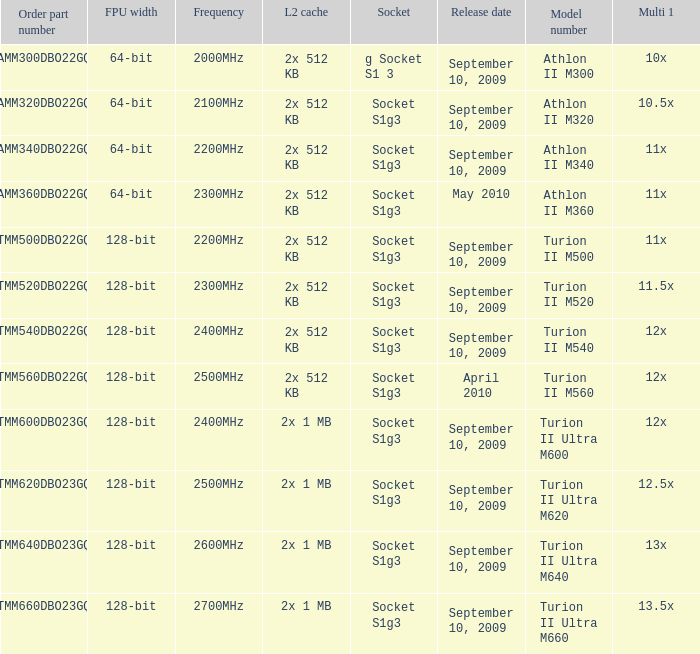What is the L2 cache with a release date on September 10, 2009, a 128-bit FPU width, and a 12x multi 1? 2x 512 KB, 2x 1 MB. Can you give me this table as a dict? {'header': ['Order part number', 'FPU width', 'Frequency', 'L2 cache', 'Socket', 'Release date', 'Model number', 'Multi 1'], 'rows': [['AMM300DBO22GQ', '64-bit', '2000MHz', '2x 512 KB', 'g Socket S1 3', 'September 10, 2009', 'Athlon II M300', '10x'], ['AMM320DBO22GQ', '64-bit', '2100MHz', '2x 512 KB', 'Socket S1g3', 'September 10, 2009', 'Athlon II M320', '10.5x'], ['AMM340DBO22GQ', '64-bit', '2200MHz', '2x 512 KB', 'Socket S1g3', 'September 10, 2009', 'Athlon II M340', '11x'], ['AMM360DBO22GQ', '64-bit', '2300MHz', '2x 512 KB', 'Socket S1g3', 'May 2010', 'Athlon II M360', '11x'], ['TMM500DBO22GQ', '128-bit', '2200MHz', '2x 512 KB', 'Socket S1g3', 'September 10, 2009', 'Turion II M500', '11x'], ['TMM520DBO22GQ', '128-bit', '2300MHz', '2x 512 KB', 'Socket S1g3', 'September 10, 2009', 'Turion II M520', '11.5x'], ['TMM540DBO22GQ', '128-bit', '2400MHz', '2x 512 KB', 'Socket S1g3', 'September 10, 2009', 'Turion II M540', '12x'], ['TMM560DBO22GQ', '128-bit', '2500MHz', '2x 512 KB', 'Socket S1g3', 'April 2010', 'Turion II M560', '12x'], ['TMM600DBO23GQ', '128-bit', '2400MHz', '2x 1 MB', 'Socket S1g3', 'September 10, 2009', 'Turion II Ultra M600', '12x'], ['TMM620DBO23GQ', '128-bit', '2500MHz', '2x 1 MB', 'Socket S1g3', 'September 10, 2009', 'Turion II Ultra M620', '12.5x'], ['TMM640DBO23GQ', '128-bit', '2600MHz', '2x 1 MB', 'Socket S1g3', 'September 10, 2009', 'Turion II Ultra M640', '13x'], ['TMM660DBO23GQ', '128-bit', '2700MHz', '2x 1 MB', 'Socket S1g3', 'September 10, 2009', 'Turion II Ultra M660', '13.5x']]} 